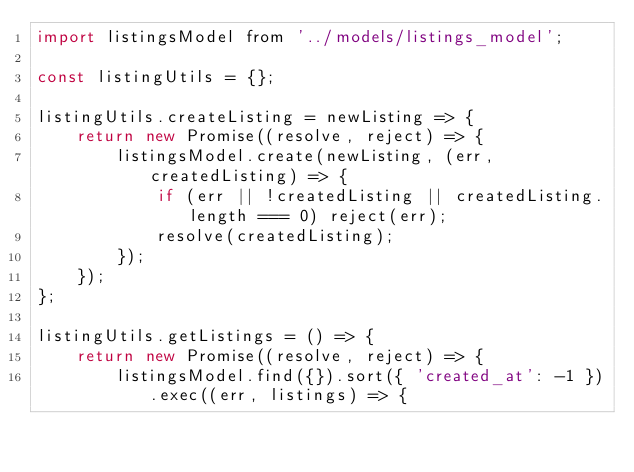Convert code to text. <code><loc_0><loc_0><loc_500><loc_500><_JavaScript_>import listingsModel from '../models/listings_model';

const listingUtils = {};

listingUtils.createListing = newListing => {
    return new Promise((resolve, reject) => {
        listingsModel.create(newListing, (err, createdListing) => {
            if (err || !createdListing || createdListing.length === 0) reject(err);
            resolve(createdListing);
        });
    });
};

listingUtils.getListings = () => {
    return new Promise((resolve, reject) => {
        listingsModel.find({}).sort({ 'created_at': -1 }).exec((err, listings) => {</code> 